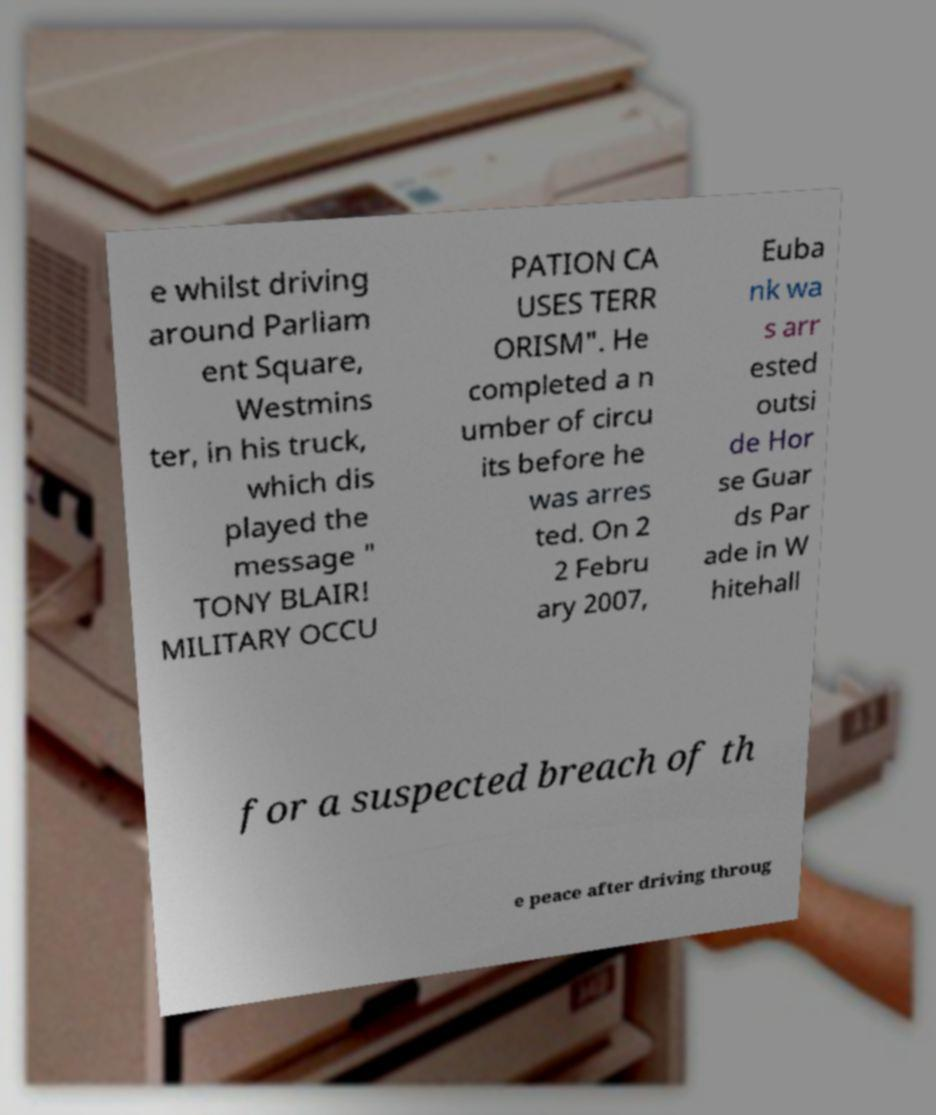For documentation purposes, I need the text within this image transcribed. Could you provide that? e whilst driving around Parliam ent Square, Westmins ter, in his truck, which dis played the message " TONY BLAIR! MILITARY OCCU PATION CA USES TERR ORISM". He completed a n umber of circu its before he was arres ted. On 2 2 Febru ary 2007, Euba nk wa s arr ested outsi de Hor se Guar ds Par ade in W hitehall for a suspected breach of th e peace after driving throug 